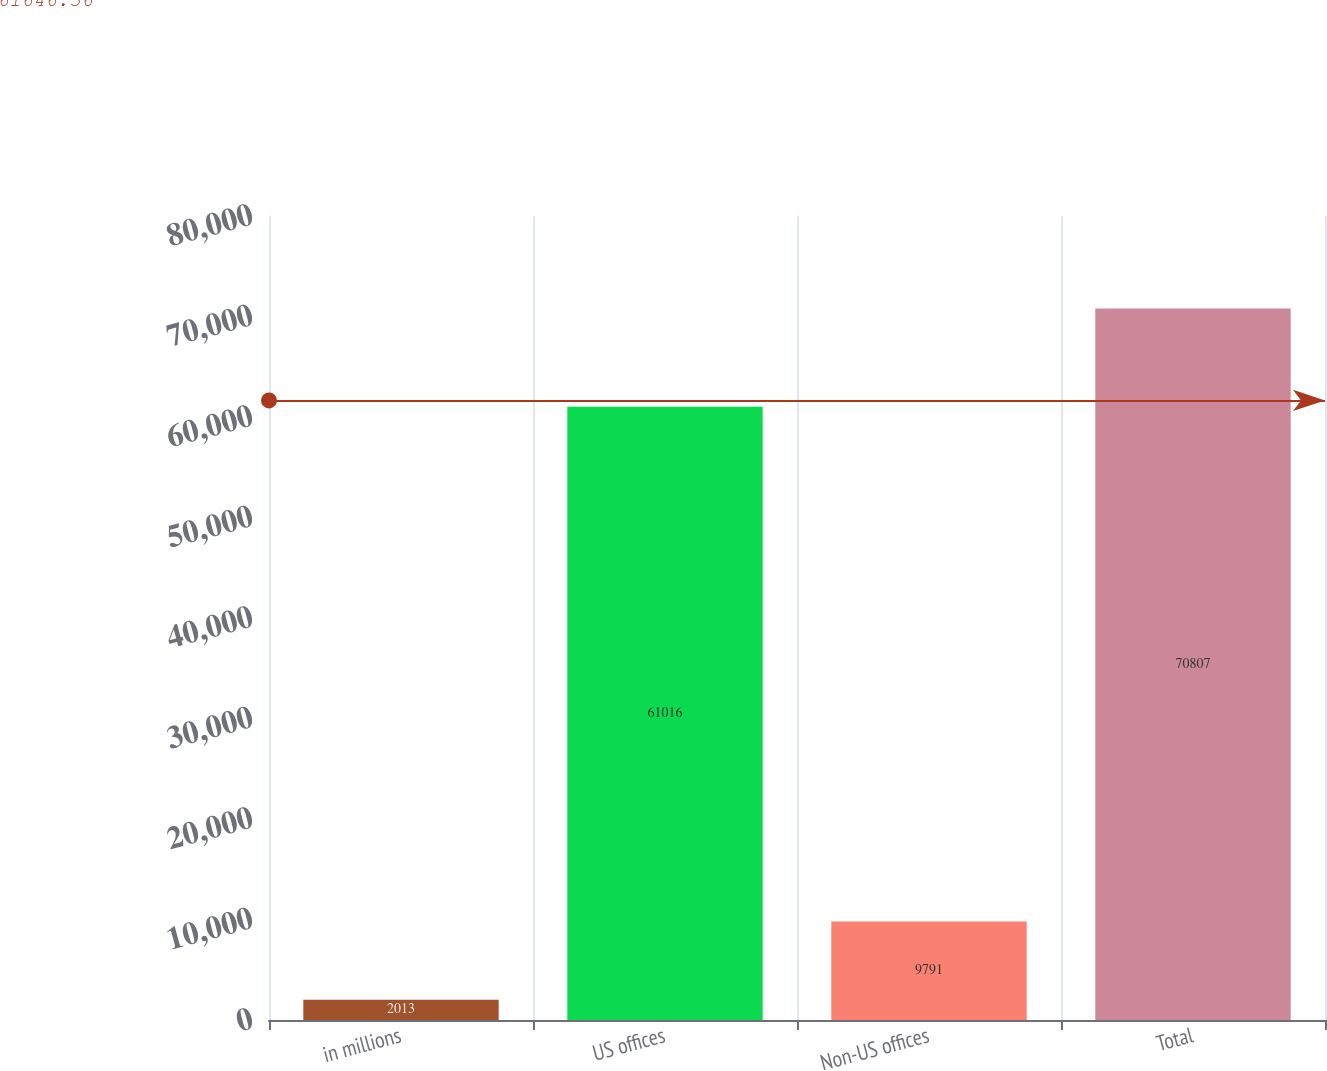Convert chart. <chart><loc_0><loc_0><loc_500><loc_500><bar_chart><fcel>in millions<fcel>US offices<fcel>Non-US offices<fcel>Total<nl><fcel>2013<fcel>61016<fcel>9791<fcel>70807<nl></chart> 